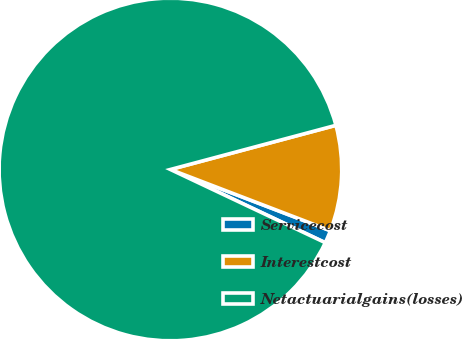Convert chart to OTSL. <chart><loc_0><loc_0><loc_500><loc_500><pie_chart><fcel>Servicecost<fcel>Interestcost<fcel>Netactuarialgains(losses)<nl><fcel>1.21%<fcel>9.97%<fcel>88.83%<nl></chart> 